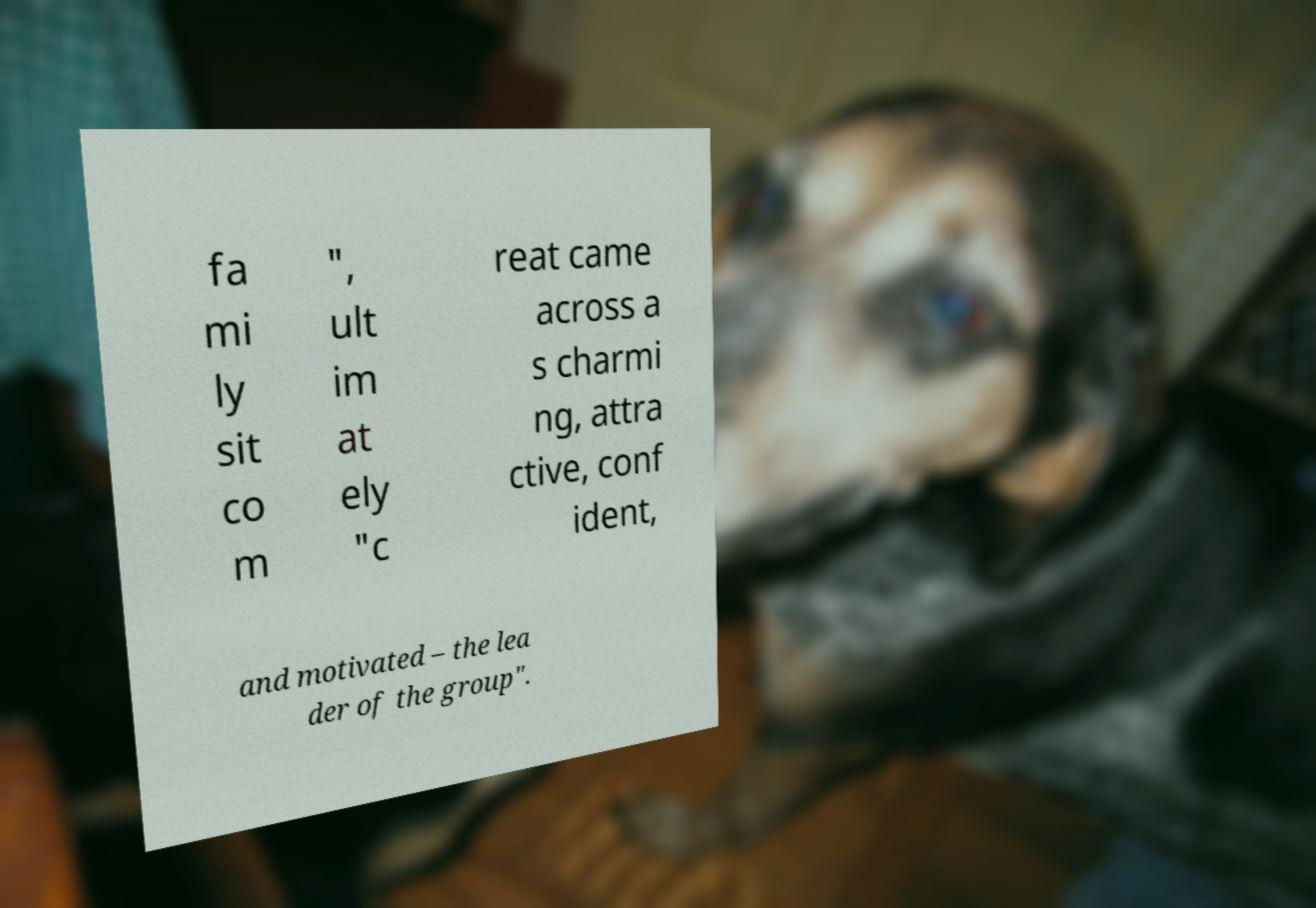Please read and relay the text visible in this image. What does it say? fa mi ly sit co m ", ult im at ely "c reat came across a s charmi ng, attra ctive, conf ident, and motivated – the lea der of the group". 